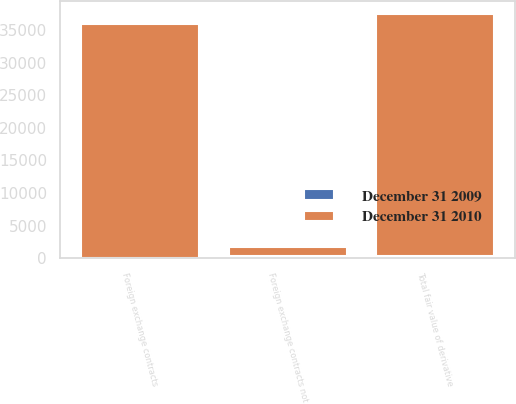Convert chart to OTSL. <chart><loc_0><loc_0><loc_500><loc_500><stacked_bar_chart><ecel><fcel>Foreign exchange contracts<fcel>Foreign exchange contracts not<fcel>Total fair value of derivative<nl><fcel>December 31 2009<fcel>27<fcel>335<fcel>362<nl><fcel>December 31 2010<fcel>35853<fcel>1343<fcel>37196<nl></chart> 